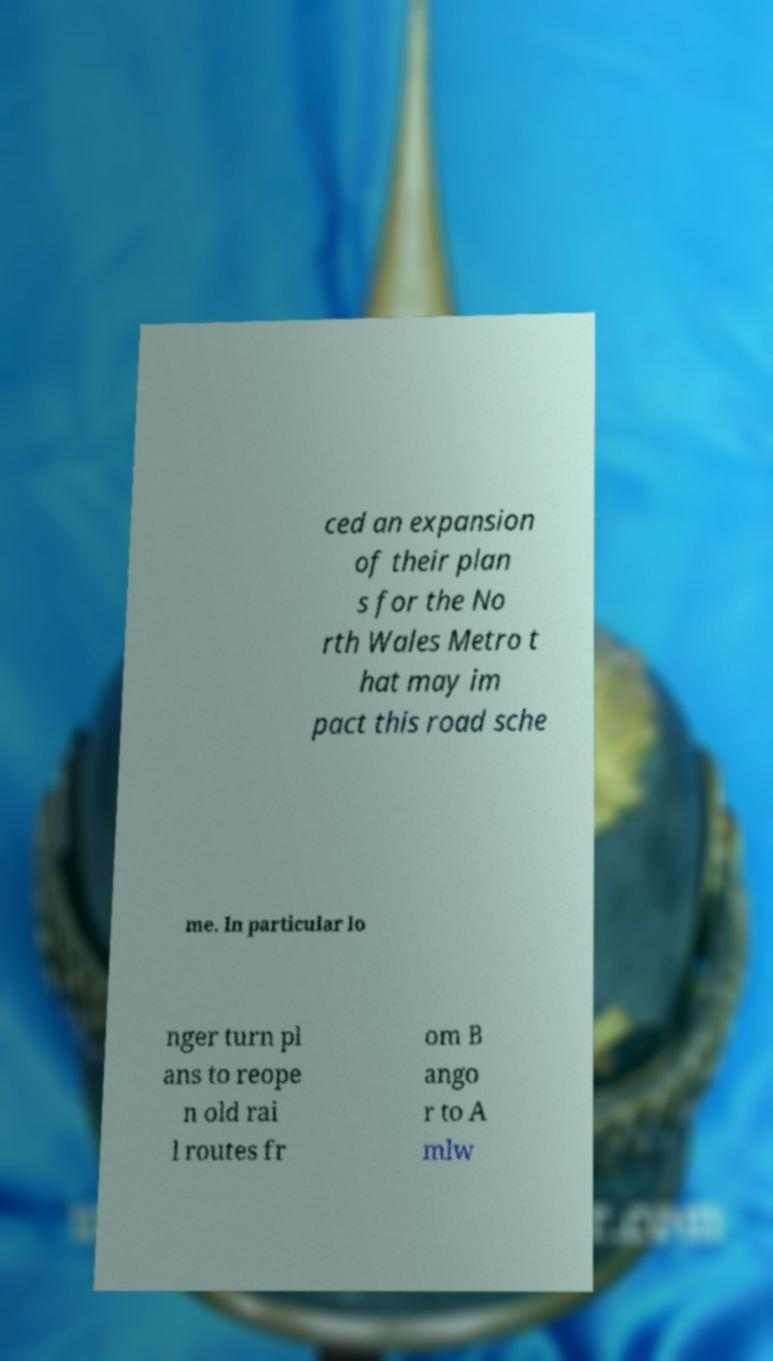Please identify and transcribe the text found in this image. ced an expansion of their plan s for the No rth Wales Metro t hat may im pact this road sche me. In particular lo nger turn pl ans to reope n old rai l routes fr om B ango r to A mlw 